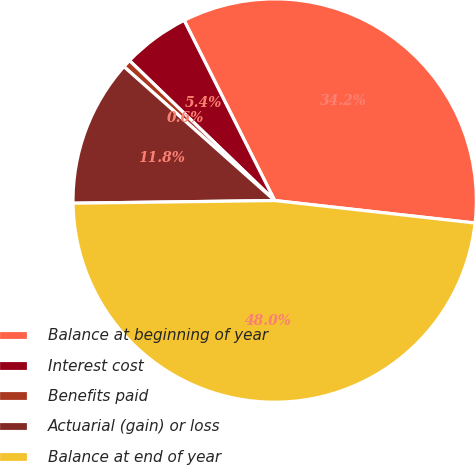Convert chart. <chart><loc_0><loc_0><loc_500><loc_500><pie_chart><fcel>Balance at beginning of year<fcel>Interest cost<fcel>Benefits paid<fcel>Actuarial (gain) or loss<fcel>Balance at end of year<nl><fcel>34.19%<fcel>5.38%<fcel>0.65%<fcel>11.77%<fcel>48.01%<nl></chart> 